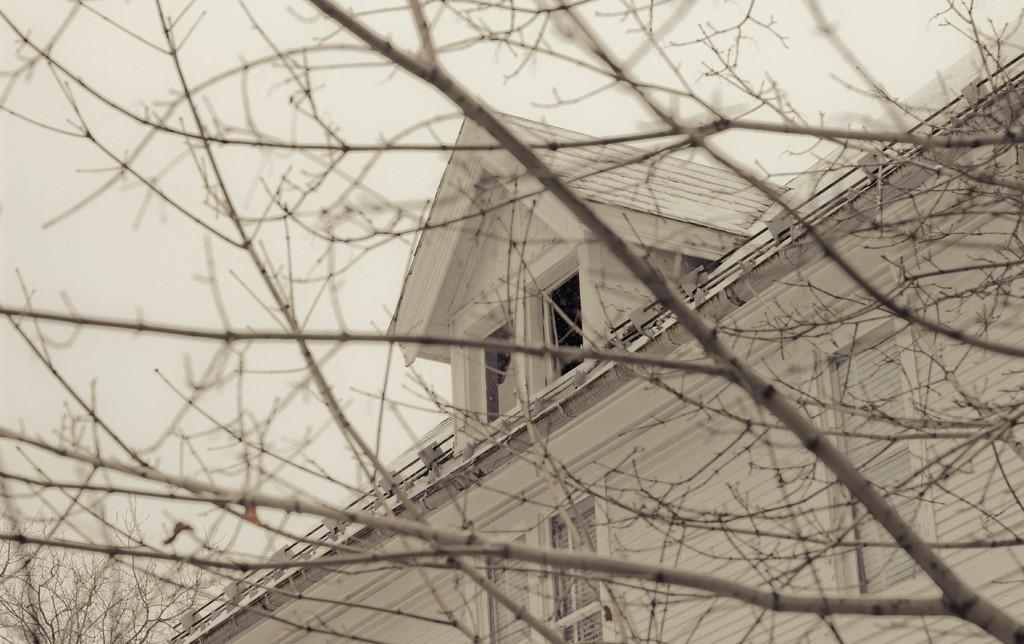Please provide a concise description of this image. Here in this picture we can see a house with number of windows present on it over there and in the front we can see branches of the tree present over there. 